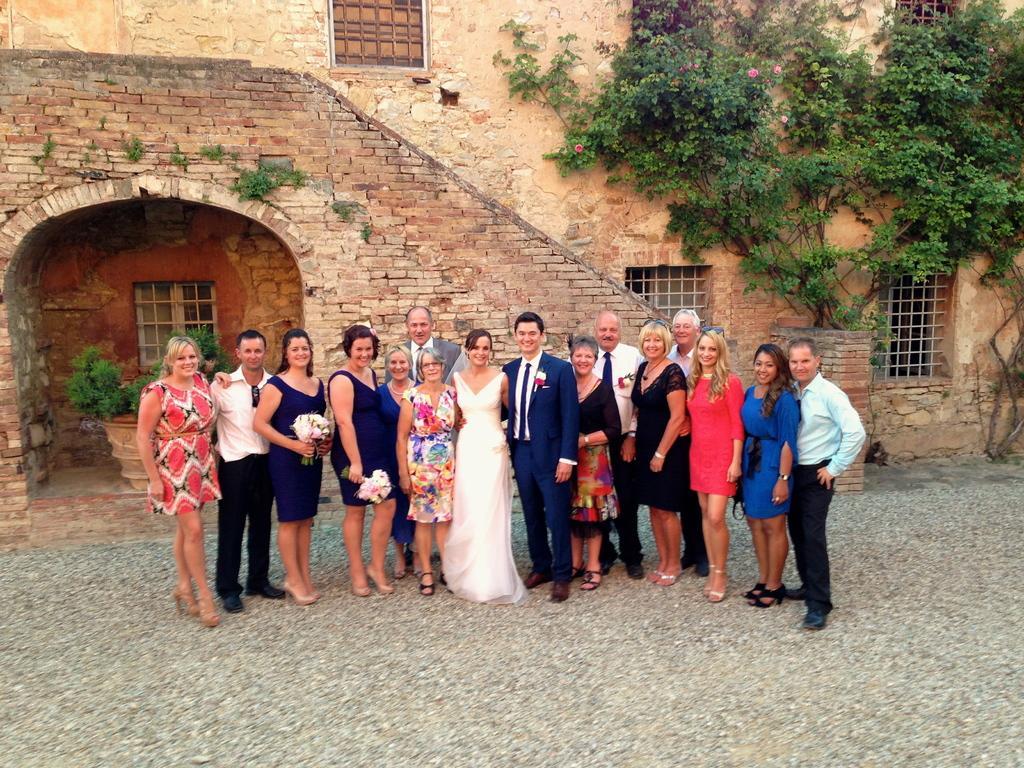Could you give a brief overview of what you see in this image? In this image there are group of people standing and smiling, there are two persons holding the bouquets, and in the background there are plants and a building. 